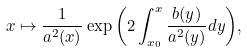<formula> <loc_0><loc_0><loc_500><loc_500>x \mapsto \frac { 1 } { a ^ { 2 } ( x ) } \, { \exp \left ( 2 \int _ { x _ { 0 } } ^ { x } \frac { b ( y ) } { a ^ { 2 } ( y ) } d y \right ) } ,</formula> 